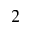Convert formula to latex. <formula><loc_0><loc_0><loc_500><loc_500>2</formula> 